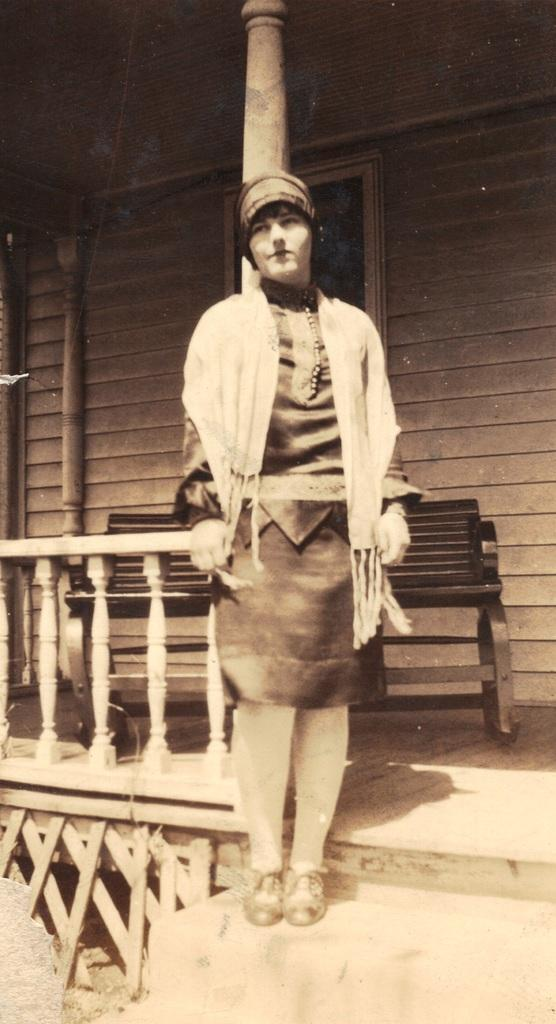What type of photograph is in the image? The image contains a black and white photograph. Who or what is in the photograph? There is a person in the photograph. What is the setting of the photograph? The person is standing near a home. Are there any architectural features in the photograph? Yes, there is a pillar and a railing in the photograph. What is the person in the photograph wearing? The person is wearing a cap. What type of toys can be seen in the photograph? There are no toys visible in the photograph; it features a person standing near a home with a pillar and a railing. 